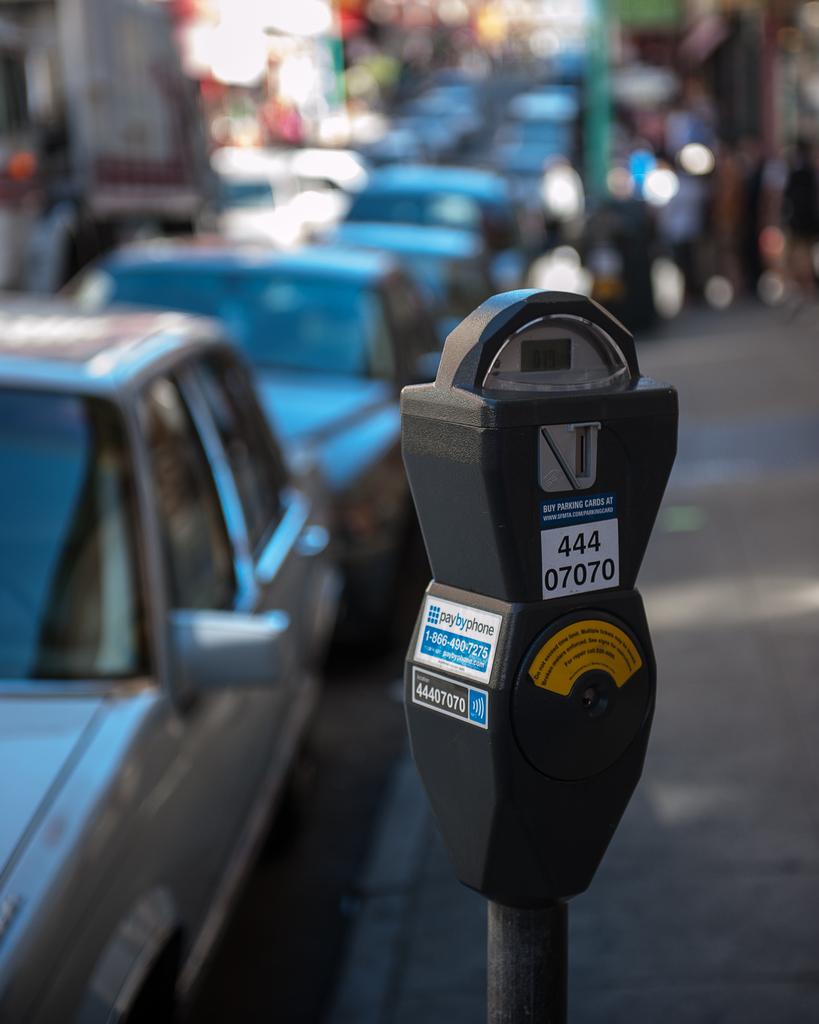What is the meter number below 444?
Offer a terse response. 07070. 